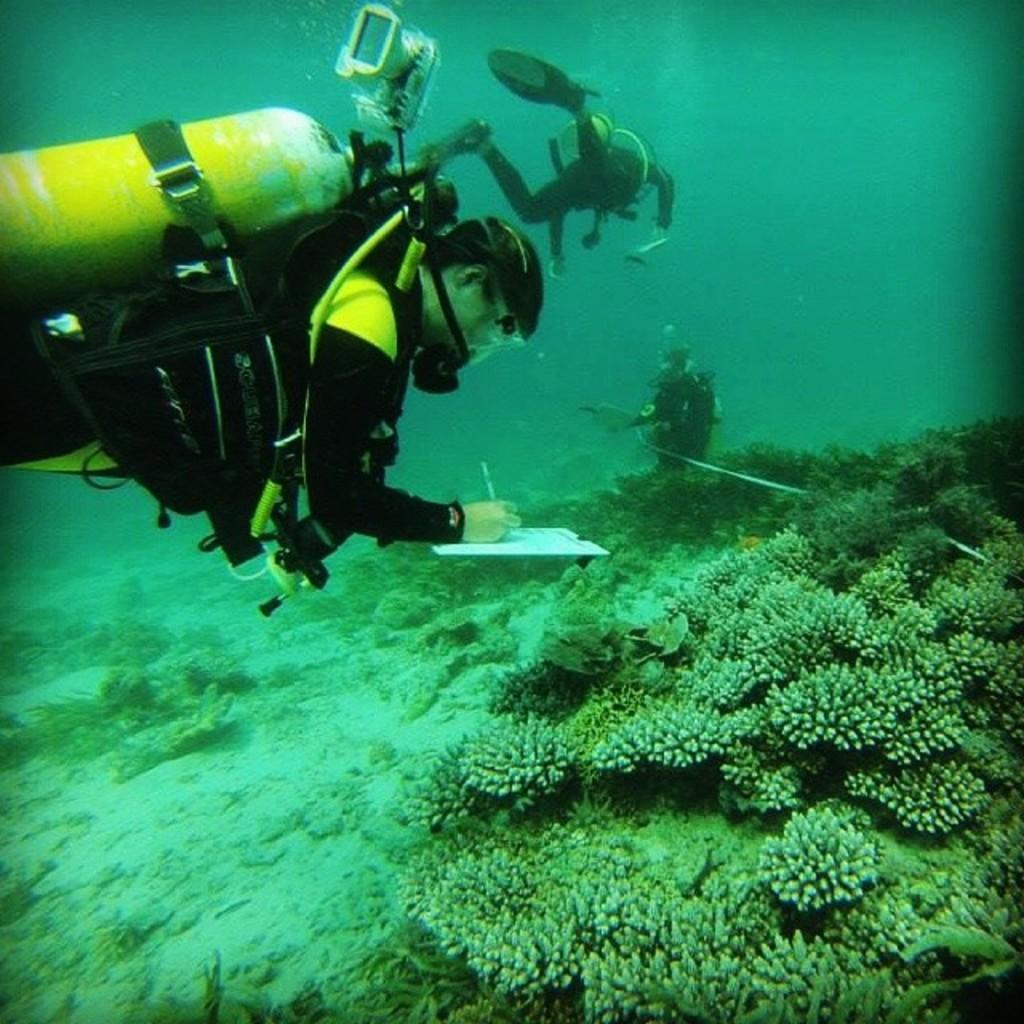In one or two sentences, can you explain what this image depicts? This picture describes about under water environment, in the water we can see few plants and group of people, they wore scuba diving suits and a person is writing with the help of pen. 